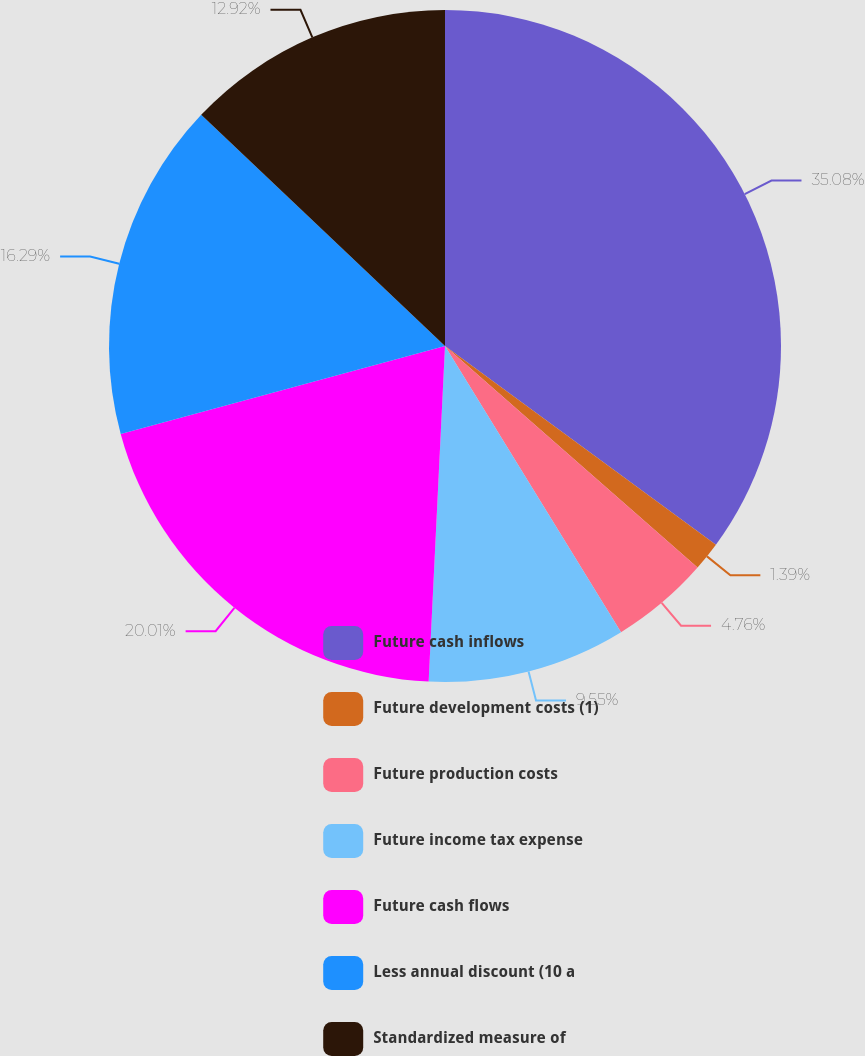<chart> <loc_0><loc_0><loc_500><loc_500><pie_chart><fcel>Future cash inflows<fcel>Future development costs (1)<fcel>Future production costs<fcel>Future income tax expense<fcel>Future cash flows<fcel>Less annual discount (10 a<fcel>Standardized measure of<nl><fcel>35.07%<fcel>1.39%<fcel>4.76%<fcel>9.55%<fcel>20.01%<fcel>16.29%<fcel>12.92%<nl></chart> 